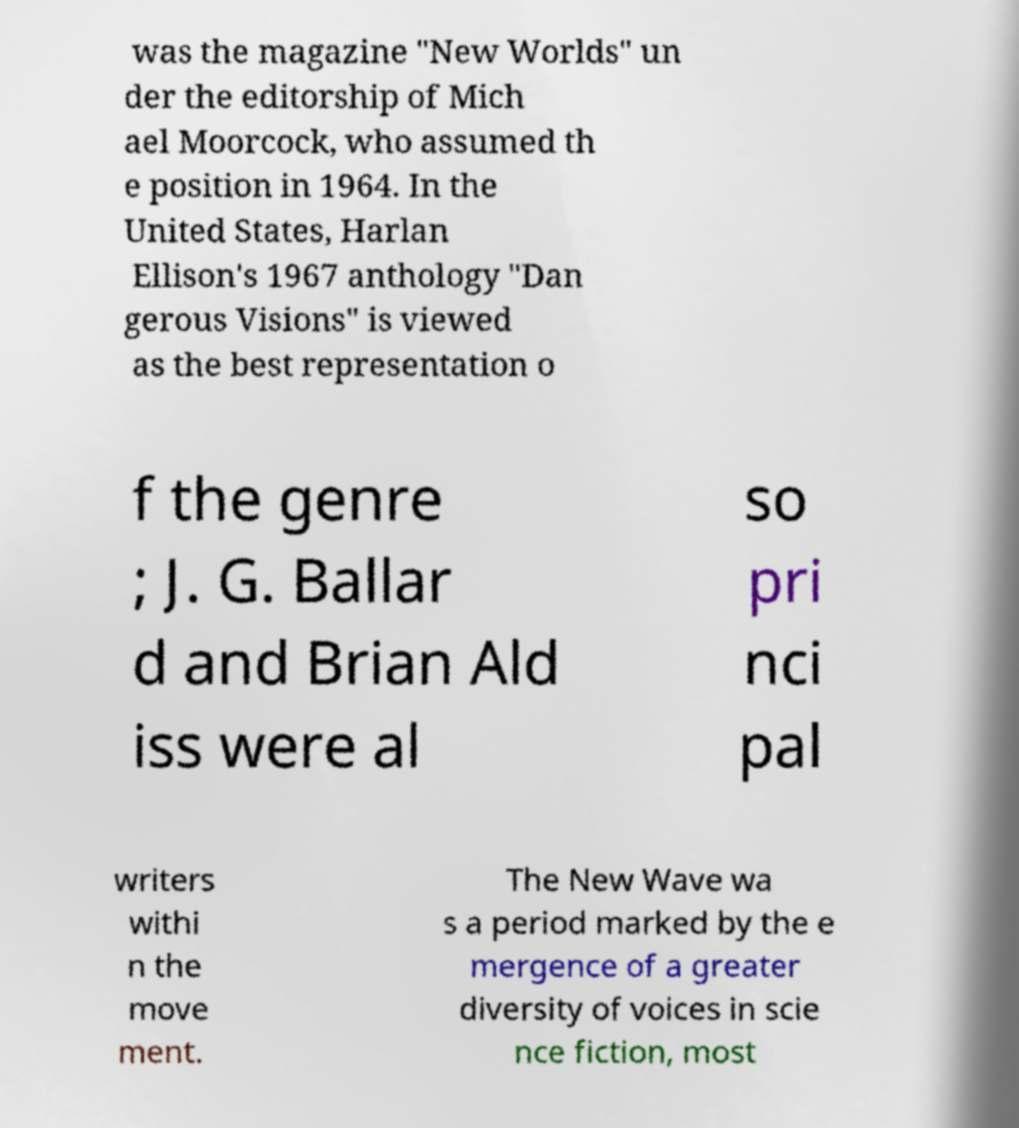Please read and relay the text visible in this image. What does it say? was the magazine "New Worlds" un der the editorship of Mich ael Moorcock, who assumed th e position in 1964. In the United States, Harlan Ellison's 1967 anthology "Dan gerous Visions" is viewed as the best representation o f the genre ; J. G. Ballar d and Brian Ald iss were al so pri nci pal writers withi n the move ment. The New Wave wa s a period marked by the e mergence of a greater diversity of voices in scie nce fiction, most 